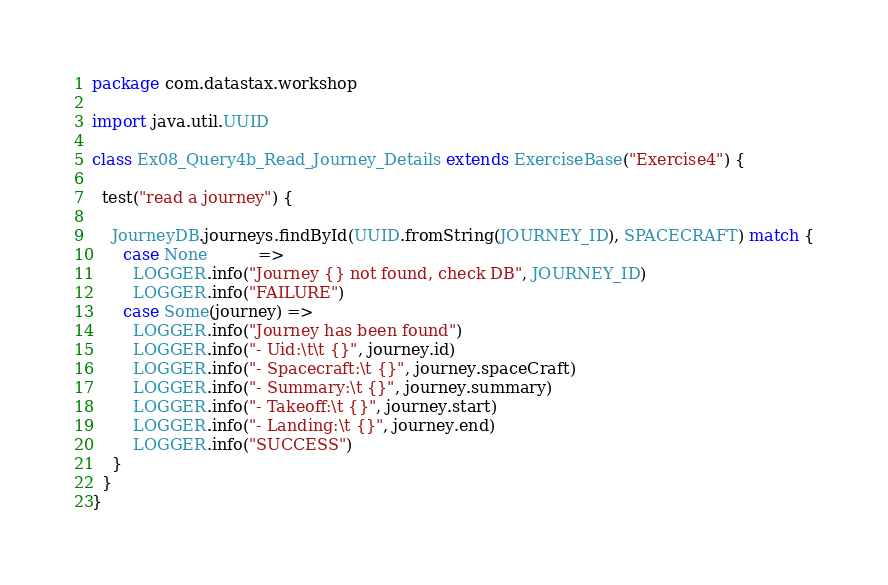<code> <loc_0><loc_0><loc_500><loc_500><_Scala_>package com.datastax.workshop

import java.util.UUID

class Ex08_Query4b_Read_Journey_Details extends ExerciseBase("Exercise4") {

  test("read a journey") {

    JourneyDB.journeys.findById(UUID.fromString(JOURNEY_ID), SPACECRAFT) match {
      case None          =>
        LOGGER.info("Journey {} not found, check DB", JOURNEY_ID)
        LOGGER.info("FAILURE")
      case Some(journey) =>
        LOGGER.info("Journey has been found")
        LOGGER.info("- Uid:\t\t {}", journey.id)
        LOGGER.info("- Spacecraft:\t {}", journey.spaceCraft)
        LOGGER.info("- Summary:\t {}", journey.summary)
        LOGGER.info("- Takeoff:\t {}", journey.start)
        LOGGER.info("- Landing:\t {}", journey.end)
        LOGGER.info("SUCCESS")
    }
  }
}
</code> 